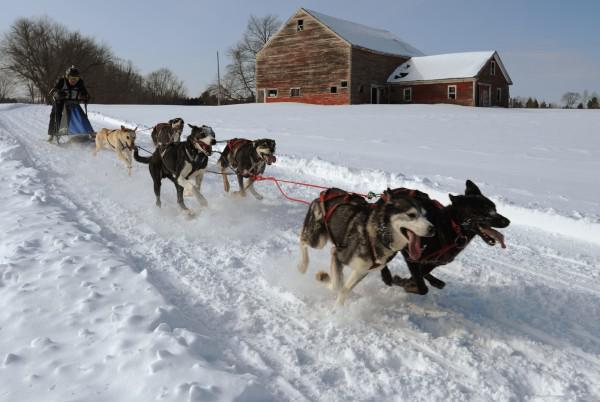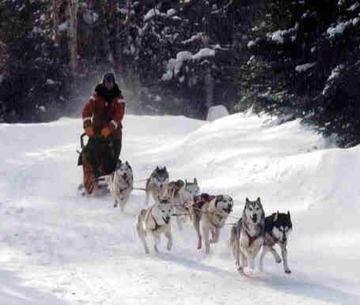The first image is the image on the left, the second image is the image on the right. Examine the images to the left and right. Is the description "A manmade shelter for people is in the background behind a sled dog team moving rightward." accurate? Answer yes or no. Yes. The first image is the image on the left, the second image is the image on the right. Examine the images to the left and right. Is the description "The left image contains exactly six sled dogs." accurate? Answer yes or no. Yes. 